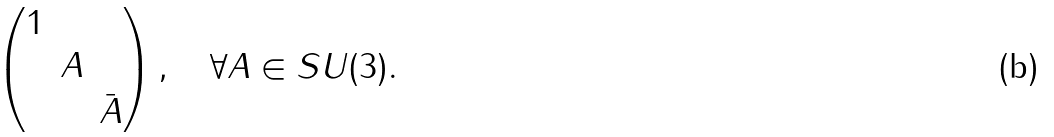Convert formula to latex. <formula><loc_0><loc_0><loc_500><loc_500>\begin{pmatrix} 1 & & \\ & A & \\ & & \bar { A } \end{pmatrix} , \quad \forall A \in S U ( 3 ) .</formula> 